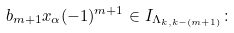<formula> <loc_0><loc_0><loc_500><loc_500>b _ { m + 1 } x _ { \alpha } ( - 1 ) ^ { m + 1 } \in I _ { \Lambda _ { k , k - ( m + 1 ) } } \colon</formula> 